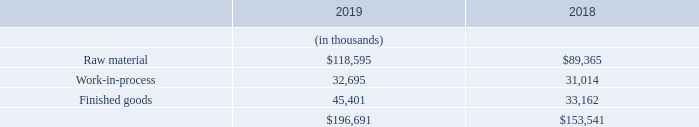F. INVENTORIES
Inventories, net consisted of the following at December 31, 2019 and 2018:
Inventory reserves for the years ended December 31, 2019 and 2018 were $103.6 million and $100.8 million, respectively.
What was the inventory reserves in 2019? $103.6 million. In which years was net inventories calculated? 2019, 2018. What were the components included in net inventories in the table? Raw material, work-in-process, finished goods. In which year was Work-in-process larger? 32,695>31,014
Answer: 2019. What was the change in Finished goods from 2018 to 2019?
Answer scale should be: thousand. 45,401-33,162
Answer: 12239. What was the percentage change in Finished goods from 2018 to 2019?
Answer scale should be: percent. (45,401-33,162)/33,162
Answer: 36.91. 